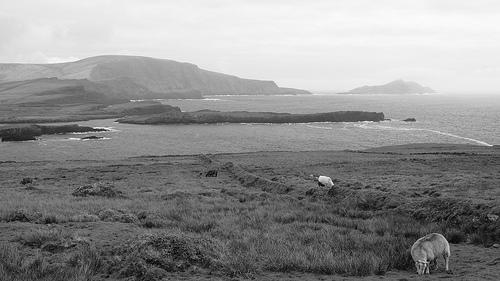Identify the main elements of this outdoor scene. Open body of water, grazing animals, fields of grass, island, cliff, mountains, clouds, rocks in water, and sheep. Count the total number of rocks in the water depicted in this image. There are at least three rocks in the water. How many sheep are present in the image? There are at least five sheep in the image. What are the characteristics of the sky in this image? The sky has a few clouds, clear, and appears grey and foggy. Consider the elements present in the image to estimate the time of day. It is daytime, although the sky appears grey and foggy. Examine the image and determine the visibility and type of mountains. A few mountains are visible in the distance, some shrouded in fog and hidden by low clouds. Analyze the interaction between the sheep and their environment. The sheep are primarily interacting with the environment by grazing in the grassy fields, which are in close proximity to the water and other natural elements. Provide a qualitative assessment of the image in terms of its content and composition. The image has a harmonious composition, featuring a diverse landscape with multiple natural elements and grazing animals, which evoke a serene, picturesque ambiance. Can you provide a detailed description of the water body in this image? A large, calm, open body of water with rocks jutting out, a small island, and close to the grassy cliff. What's the probable weather condition based on the image's appearance? The weather seems to be overcast and foggy, but otherwise, calm and stable. 